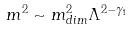<formula> <loc_0><loc_0><loc_500><loc_500>m ^ { 2 } \sim m ^ { 2 } _ { d i m } \Lambda ^ { 2 - \gamma _ { 1 } }</formula> 